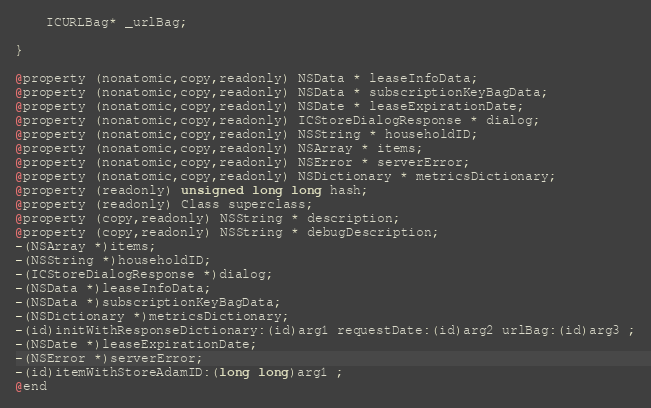Convert code to text. <code><loc_0><loc_0><loc_500><loc_500><_C_>	ICURLBag* _urlBag;

}

@property (nonatomic,copy,readonly) NSData * leaseInfoData; 
@property (nonatomic,copy,readonly) NSData * subscriptionKeyBagData; 
@property (nonatomic,copy,readonly) NSDate * leaseExpirationDate; 
@property (nonatomic,copy,readonly) ICStoreDialogResponse * dialog; 
@property (nonatomic,copy,readonly) NSString * householdID; 
@property (nonatomic,copy,readonly) NSArray * items; 
@property (nonatomic,copy,readonly) NSError * serverError; 
@property (nonatomic,copy,readonly) NSDictionary * metricsDictionary; 
@property (readonly) unsigned long long hash; 
@property (readonly) Class superclass; 
@property (copy,readonly) NSString * description; 
@property (copy,readonly) NSString * debugDescription; 
-(NSArray *)items;
-(NSString *)householdID;
-(ICStoreDialogResponse *)dialog;
-(NSData *)leaseInfoData;
-(NSData *)subscriptionKeyBagData;
-(NSDictionary *)metricsDictionary;
-(id)initWithResponseDictionary:(id)arg1 requestDate:(id)arg2 urlBag:(id)arg3 ;
-(NSDate *)leaseExpirationDate;
-(NSError *)serverError;
-(id)itemWithStoreAdamID:(long long)arg1 ;
@end

</code> 